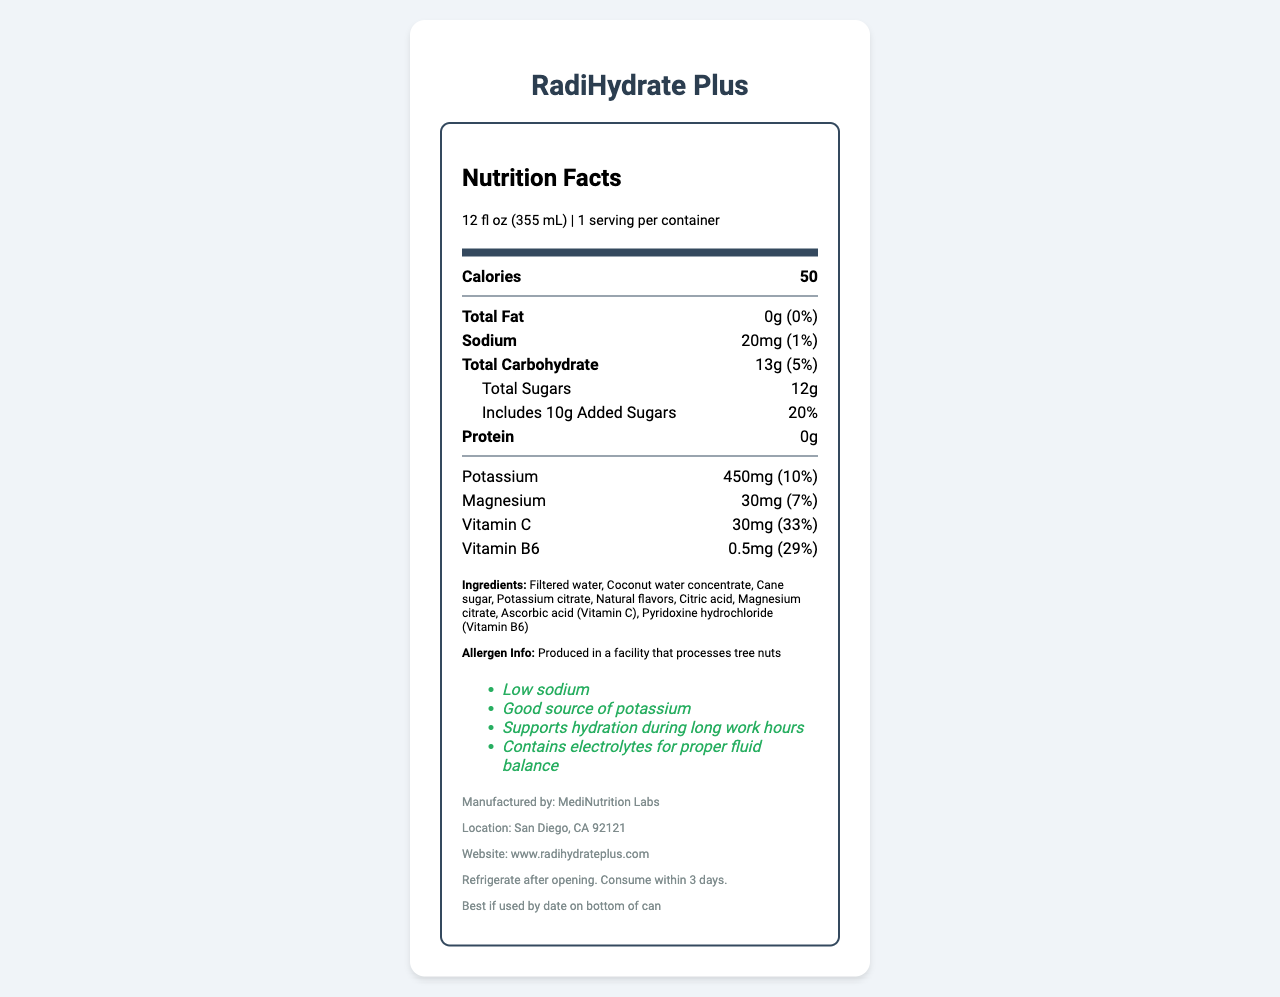what is the serving size? The serving size information is provided at the beginning of the Nutritional Facts section.
Answer: 12 fl oz (355 mL) how many calories are in one serving? The number of calories per serving is listed at the top of the Nutritional Facts.
Answer: 50 what is the amount of sodium per serving? The document lists the sodium content in the nutrient section under Sodium.
Answer: 20mg how much potassium does this beverage contain per serving? The potassium content is provided in the nutrient section.
Answer: 450mg what percentage of the daily value does the sodium content represent? The percentage of daily value for sodium is listed next to its amount in the Nutritional Facts.
Answer: 1% which of the following vitamins has the highest daily value percentage in this beverage? A. Vitamin C B. Vitamin B6 C. Magnesium The daily value percentages are: Vitamin C (33%), Vitamin B6 (29%), and Magnesium (7%).
Answer: A. Vitamin C what ingredient is listed first in the ingredients section? Ingredients are listed in descending order of weight, with filtered water being the first.
Answer: Filtered water does this beverage contain any added sugars? The Nutritional Facts section under "Total Sugars" specifies that the beverage includes 10g of added sugars.
Answer: Yes what manufacturer produces this beverage? The manufacturer's information is provided in the manufacturer info section.
Answer: MediNutrition Labs where is this beverage manufactured? The manufacturing location is listed under the manufacturer info section.
Answer: San Diego, CA 92121 is this beverage a good source of potassium? One of the health claims specifically mentions that it is a good source of potassium.
Answer: Yes describe the main idea of the document. The document focuses on presenting all the necessary information about the RadiHydrate Plus beverage, including its nutritional benefits, composition, and usage instructions, to ensure it supports hydration for healthcare professionals.
Answer: RadiHydrate Plus is a low-sodium, potassium-rich beverage designed specifically for healthcare professionals, especially radiologists, to maintain proper hydration and electrolyte balance during long shifts. The document provides detailed nutritional information, ingredients, health claims, manufacturer details, and storage instructions. can this beverage help with proper fluid balance? One of the health claims states that it contains electrolytes for proper fluid balance.
Answer: Yes how much sugar is naturally occurring in this beverage? The total sugars are 12g, out of which 10g are added sugars, indicating 2g of naturally occurring sugars.
Answer: 2g how should the beverage be stored after opening? A. Keep at room temperature B. Refrigerate C. Freeze The storage instructions specify to refrigerate after opening.
Answer: B. Refrigerate what is the recommended consumption time after opening the beverage? The storage instructions inform to consume within 3 days after opening.
Answer: Within 3 days what is the expiration date format for this beverage? The expiration date location and format are mentioned at the bottom of the manufacturer info section.
Answer: Best if used by date on bottom of can how much fiber does this beverage contain? The document does not provide any information about dietary fiber content.
Answer: Not enough information 